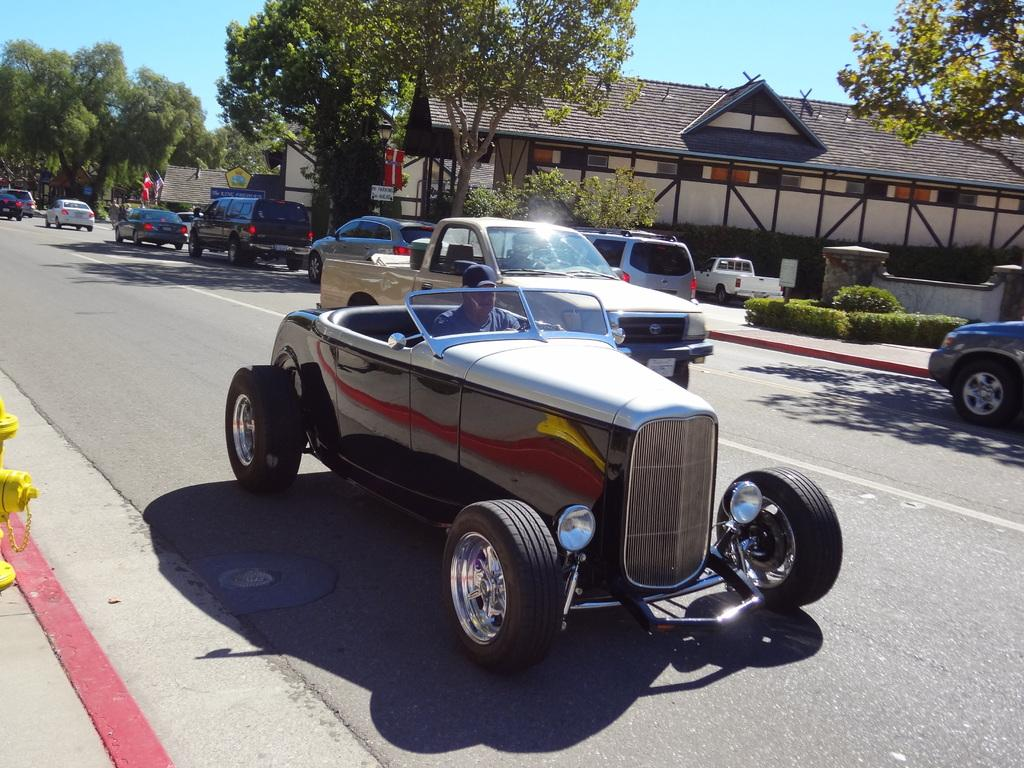What is happening on the road in the image? Cars are passing on the road in the image. What can be seen beside the road in the image? There are trees beside the road in the image. What type of structures are visible in the image? There are houses in the image. What type of crib is visible in the middle of the road in the image? There is no crib present in the image; it only shows cars passing on the road, trees beside the road, and houses. 